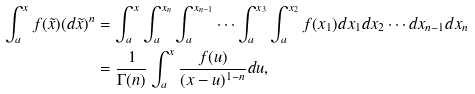<formula> <loc_0><loc_0><loc_500><loc_500>\int _ { a } ^ { x } f ( \tilde { x } ) ( d \tilde { x } ) ^ { n } & = \int _ { a } ^ { x } \int _ { a } ^ { x _ { n } } \int _ { a } ^ { x _ { n - 1 } } \cdots \int _ { a } ^ { x _ { 3 } } \int _ { a } ^ { x _ { 2 } } f ( x _ { 1 } ) d x _ { 1 } d x _ { 2 } \cdots d x _ { n - 1 } d x _ { n } \\ & = \frac { 1 } { \Gamma ( n ) } \int _ { a } ^ { x } \frac { f ( u ) } { ( x - u ) ^ { 1 - n } } d u ,</formula> 